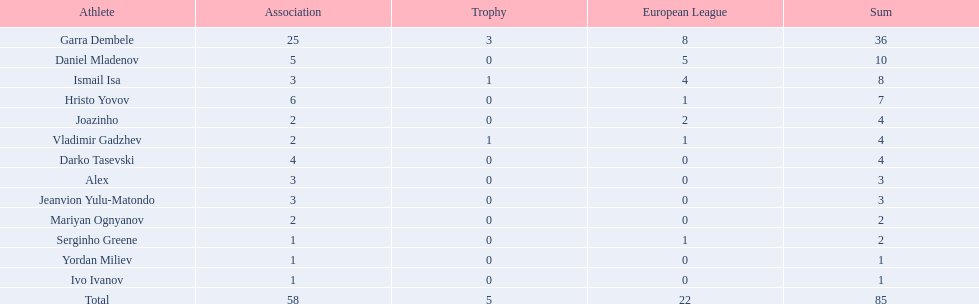What league is 2? 2, 2, 2. Which cup is less than 1? 0, 0. Could you parse the entire table as a dict? {'header': ['Athlete', 'Association', 'Trophy', 'European League', 'Sum'], 'rows': [['Garra Dembele', '25', '3', '8', '36'], ['Daniel Mladenov', '5', '0', '5', '10'], ['Ismail Isa', '3', '1', '4', '8'], ['Hristo Yovov', '6', '0', '1', '7'], ['Joazinho', '2', '0', '2', '4'], ['Vladimir Gadzhev', '2', '1', '1', '4'], ['Darko Tasevski', '4', '0', '0', '4'], ['Alex', '3', '0', '0', '3'], ['Jeanvion Yulu-Matondo', '3', '0', '0', '3'], ['Mariyan Ognyanov', '2', '0', '0', '2'], ['Serginho Greene', '1', '0', '1', '2'], ['Yordan Miliev', '1', '0', '0', '1'], ['Ivo Ivanov', '1', '0', '0', '1'], ['Total', '58', '5', '22', '85']]} Which total is 2? 2. Who is the player? Mariyan Ognyanov. 